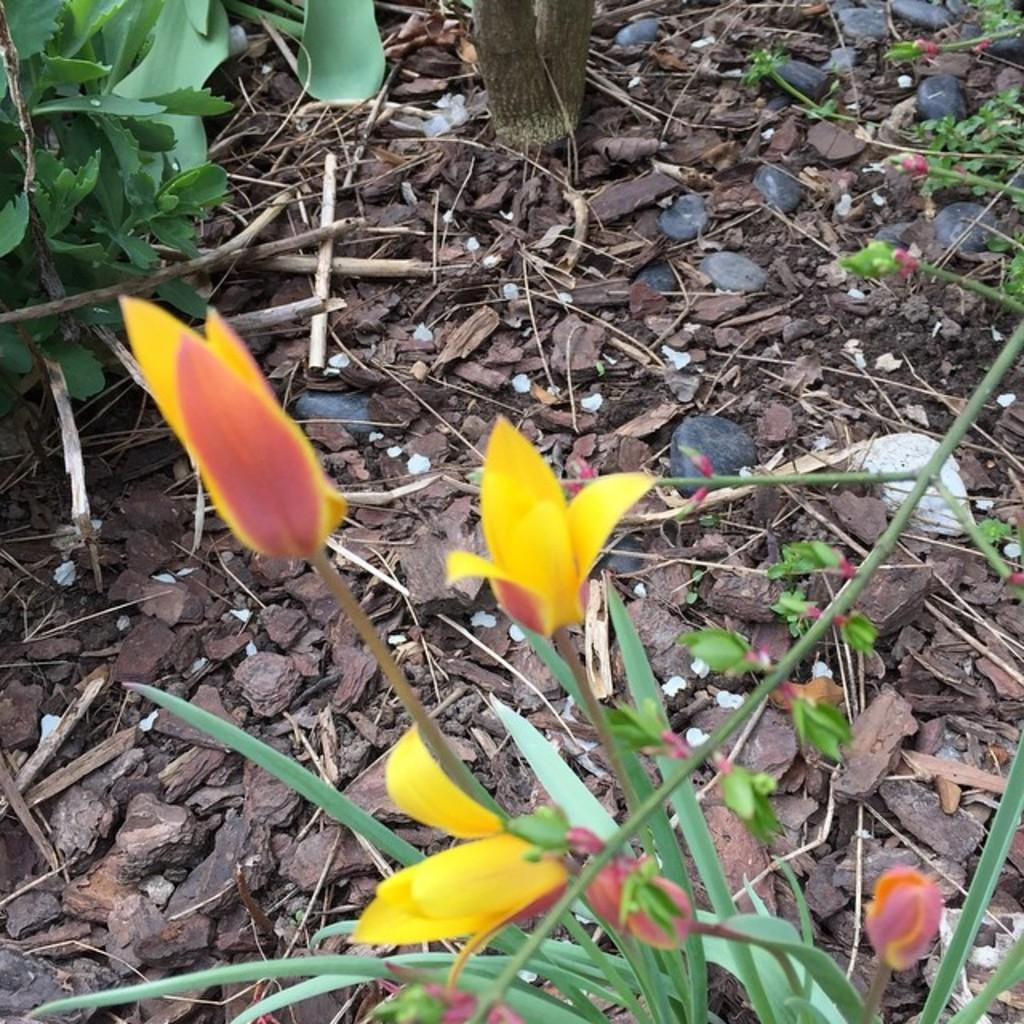What type of plants are in the image? There are flowers in the image. What colors are the flowers? The flowers are yellow and red in color. What part of the flowers can be seen in the image? There is a stem of the flower in the image. What else is present in the image besides the flowers? There are leaves, stones, soil, and pieces of wood in the image. What is the scent of the flowers in the image? The image does not provide information about the scent of the flowers, so it cannot be determined from the image. 